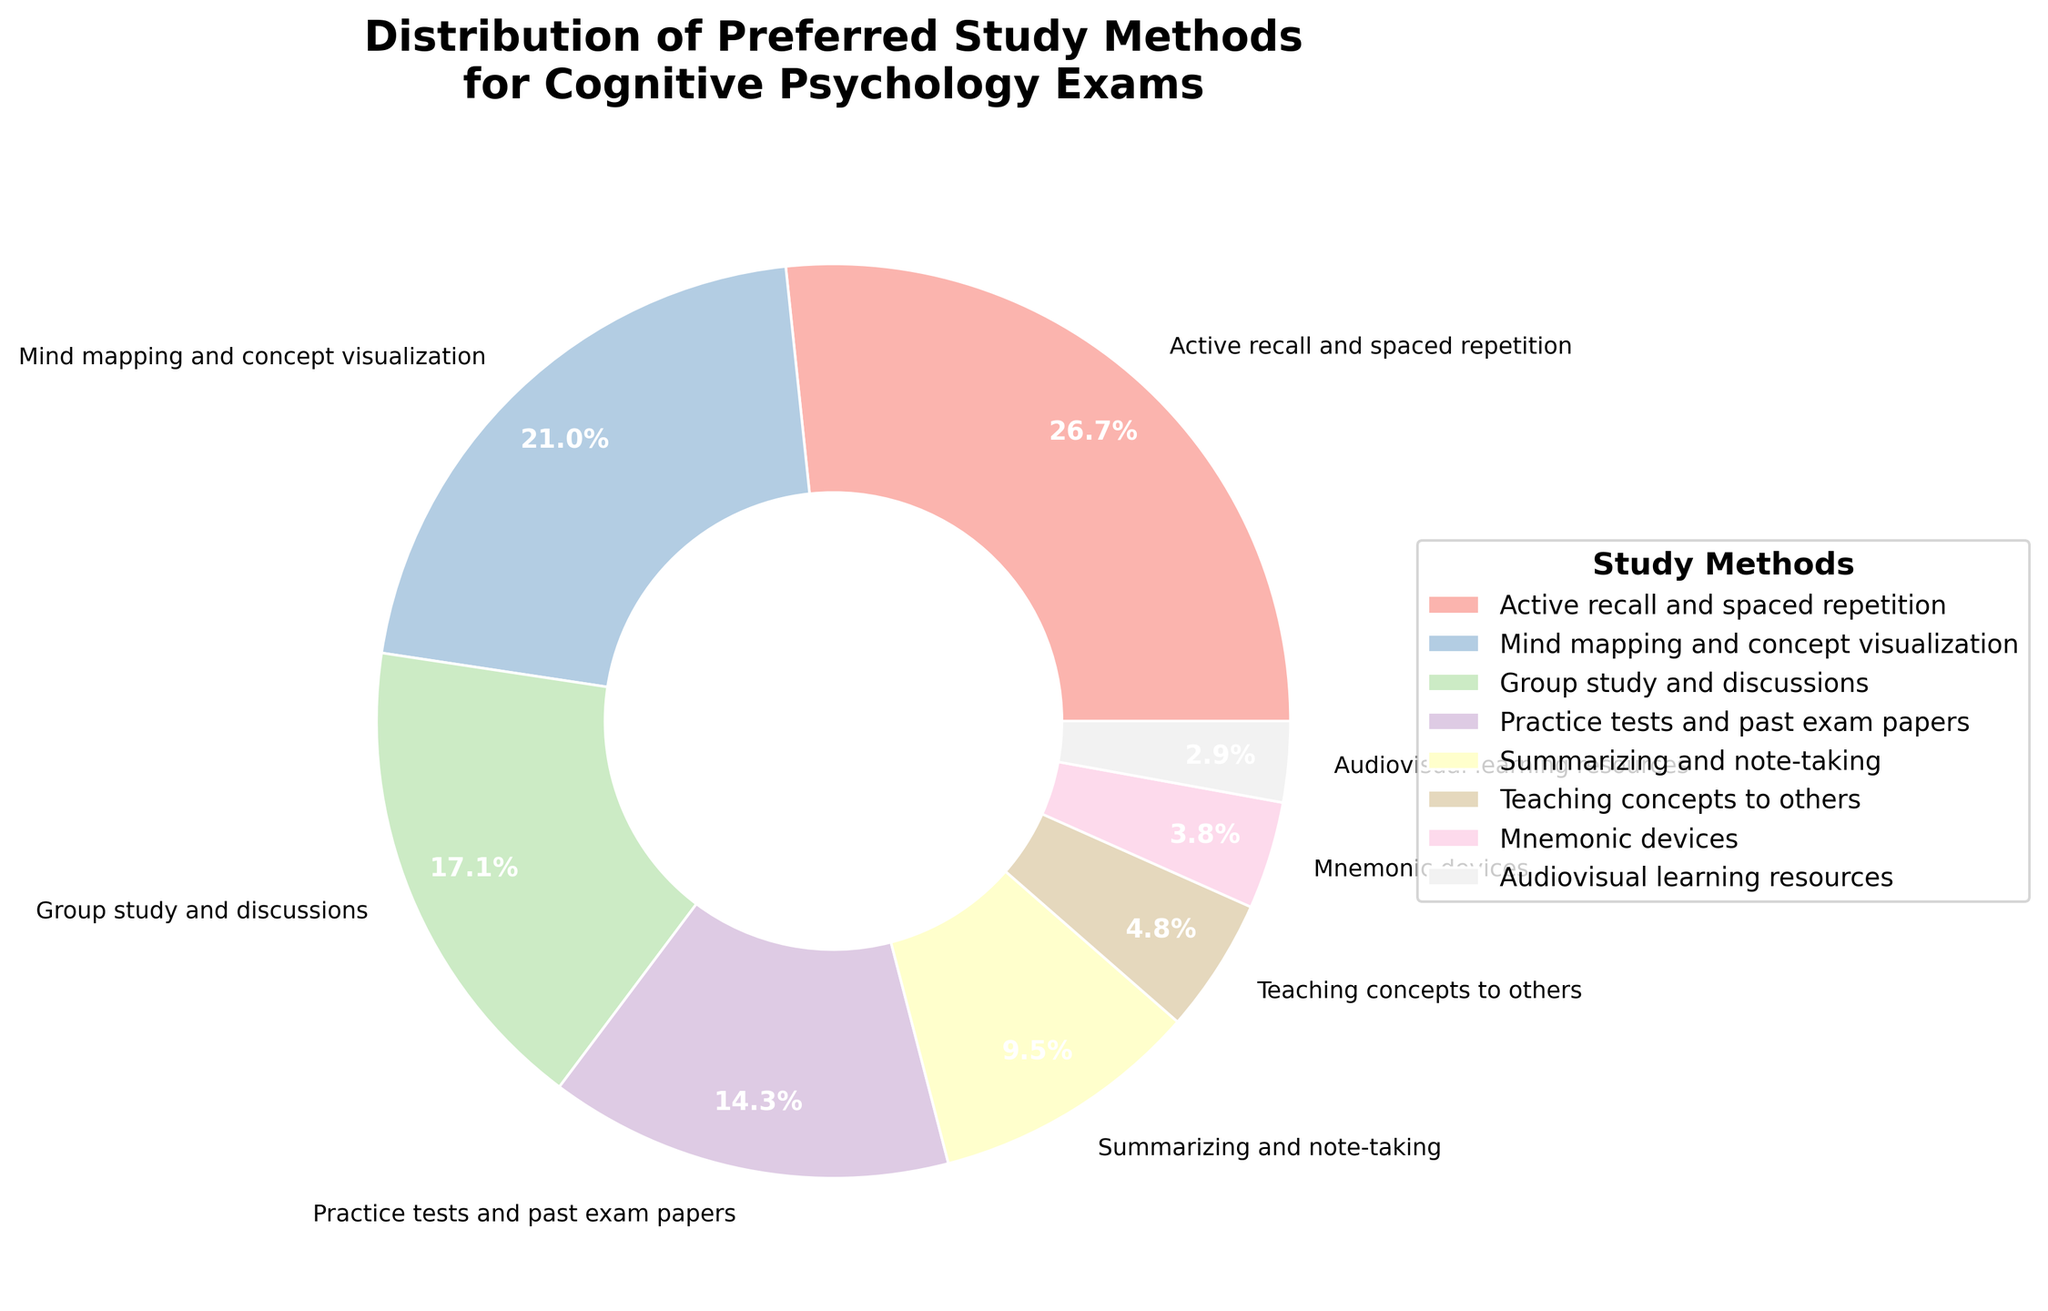What percentage of students prefer using active recall and spaced repetition? Look at the pie chart segment labeled "Active recall and spaced repetition" and read the corresponding percentage value.
Answer: 28% Which study method is the least preferred among students? Find the smallest segment in the pie chart and check the label; it is "Audiovisual learning resources."
Answer: Audiovisual learning resources What is the total percentage of students who prefer mind mapping and concept visualization, and group study and discussions combined? Add the percentages for "Mind mapping and concept visualization" (22%) and "Group study and discussions" (18%): 22 + 18 = 40%
Answer: 40% How much more popular is practice tests and past exam papers compared to summarizing and note-taking? Subtract the percentage of "Summarizing and note-taking" (10%) from "Practice tests and past exam papers" (15%): 15 - 10 = 5%
Answer: 5% What is the difference in the percentage of students preferring teaching concepts to others versus mnemonic devices? Subtract the percentage of "Mnemonic devices" (4%) from "Teaching concepts to others" (5%): 5 - 4 = 1%
Answer: 1% Rank the top three study methods preferred by students. List the methods with the highest percentages: 1. Active recall and spaced repetition (28%), 2. Mind mapping and concept visualization (22%), 3. Group study and discussions (18%)
Answer: 1. Active recall and spaced repetition, 2. Mind mapping and concept visualization, 3. Group study and discussions Which study method has a color visually different from the rest and is placed between two methods with visually larger segments? The study method placed between two larger segments visually distinct by color is "Teaching concepts to others," placed between "Summarizing and note-taking" and "Mnemonic devices."
Answer: Teaching concepts to others Which methods have percentages below 10%? Look at segments with labels and percentages less than 10%: "Teaching concepts to others" (5%), "Mnemonic devices" (4%), "Audiovisual learning resources" (3%).
Answer: Teaching concepts to others, Mnemonic devices, Audiovisual learning resources What is the average percentage of the three least preferred study methods? Add the percentages of the three least preferred methods ("Mnemonic devices" (4%), and "Audiovisual learning resources" (3%), "Teaching concepts to others" (5%)) and divide by 3: (4 + 3 + 5) / 3 = 4%
Answer: 4% Compare the popularity of group study and discussions to summarizing and note-taking. Which is more popular and by how much? Group study and discussions is more popular than summarizing and note-taking. Subtract the percentage of "Summarizing and note-taking" (10%) from "Group study and discussions" (18%): 18 - 10 = 8%.
Answer: Group study and discussions by 8% 